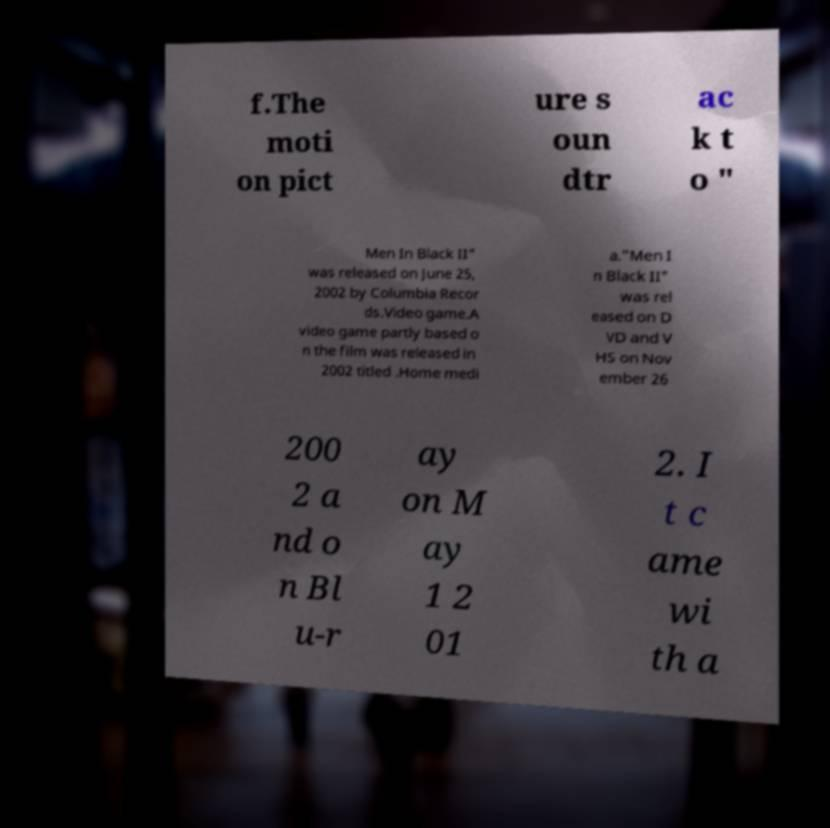Could you extract and type out the text from this image? f.The moti on pict ure s oun dtr ac k t o " Men In Black II" was released on June 25, 2002 by Columbia Recor ds.Video game.A video game partly based o n the film was released in 2002 titled .Home medi a."Men I n Black II" was rel eased on D VD and V HS on Nov ember 26 200 2 a nd o n Bl u-r ay on M ay 1 2 01 2. I t c ame wi th a 